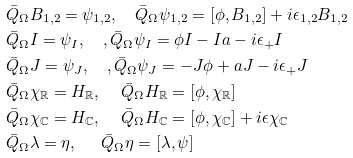<formula> <loc_0><loc_0><loc_500><loc_500>& \bar { Q } _ { \Omega } B _ { 1 , 2 } = \psi _ { 1 , 2 } , \quad \bar { Q } _ { \Omega } \psi _ { 1 , 2 } = [ \phi , B _ { 1 , 2 } ] + i \epsilon _ { 1 , 2 } B _ { 1 , 2 } \\ & \bar { Q } _ { \Omega } I = \psi _ { I } , \quad , \bar { Q } _ { \Omega } \psi _ { I } = \phi I - I a - i \epsilon _ { + } I \\ & \bar { Q } _ { \Omega } J = \psi _ { J } , \quad , \bar { Q } _ { \Omega } \psi _ { J } = - J \phi + a J - i \epsilon _ { + } J \\ & \bar { Q } _ { \Omega } \chi _ { \mathbb { R } } = H _ { \mathbb { R } } , \quad \, \bar { Q } _ { \Omega } H _ { \mathbb { R } } = [ \phi , \chi _ { \mathbb { R } } ] \\ & \bar { Q } _ { \Omega } \chi _ { \mathbb { C } } = H _ { \mathbb { C } } , \quad \, \bar { Q } _ { \Omega } H _ { \mathbb { C } } = [ \phi , \chi _ { \mathbb { C } } ] + i \epsilon \chi _ { \mathbb { C } } \\ & \bar { Q } _ { \Omega } \lambda = \eta , \quad \ \, \bar { Q } _ { \Omega } \eta = [ \lambda , \psi ]</formula> 